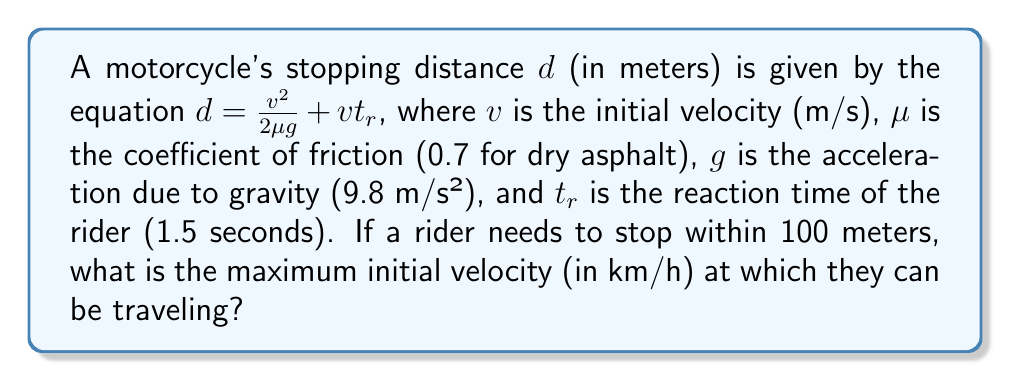What is the answer to this math problem? 1) Start with the given equation:
   $$d = \frac{v^2}{2\mu g} + vt_r$$

2) Substitute the known values:
   $$100 = \frac{v^2}{2(0.7)(9.8)} + v(1.5)$$

3) Simplify:
   $$100 = \frac{v^2}{13.72} + 1.5v$$

4) Multiply both sides by 13.72:
   $$1372 = v^2 + 20.58v$$

5) Rearrange to standard quadratic form:
   $$v^2 + 20.58v - 1372 = 0$$

6) Use the quadratic formula $\frac{-b \pm \sqrt{b^2 - 4ac}}{2a}$:
   $$v = \frac{-20.58 \pm \sqrt{20.58^2 - 4(1)(-1372)}}{2(1)}$$

7) Simplify:
   $$v = \frac{-20.58 \pm \sqrt{423.5364 + 5488}}{2}$$
   $$v = \frac{-20.58 \pm \sqrt{5911.5364}}{2}$$
   $$v = \frac{-20.58 \pm 76.89}{2}$$

8) Take the positive root:
   $$v = \frac{-20.58 + 76.89}{2} = 28.155 \text{ m/s}$$

9) Convert to km/h:
   $$28.155 \text{ m/s} \times \frac{3600 \text{ s}}{1 \text{ h}} \times \frac{1 \text{ km}}{1000 \text{ m}} = 101.358 \text{ km/h}$$
Answer: 101.36 km/h 